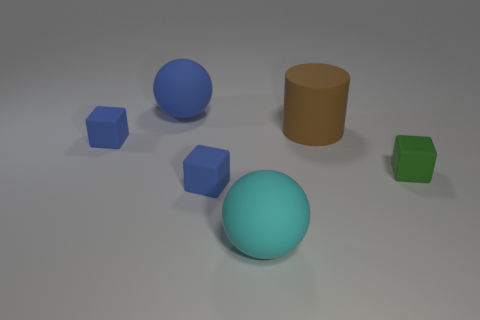Add 1 matte blocks. How many objects exist? 7 Subtract all cylinders. How many objects are left? 5 Subtract all blue shiny cubes. Subtract all blue cubes. How many objects are left? 4 Add 5 big cylinders. How many big cylinders are left? 6 Add 2 large things. How many large things exist? 5 Subtract 0 cyan cylinders. How many objects are left? 6 